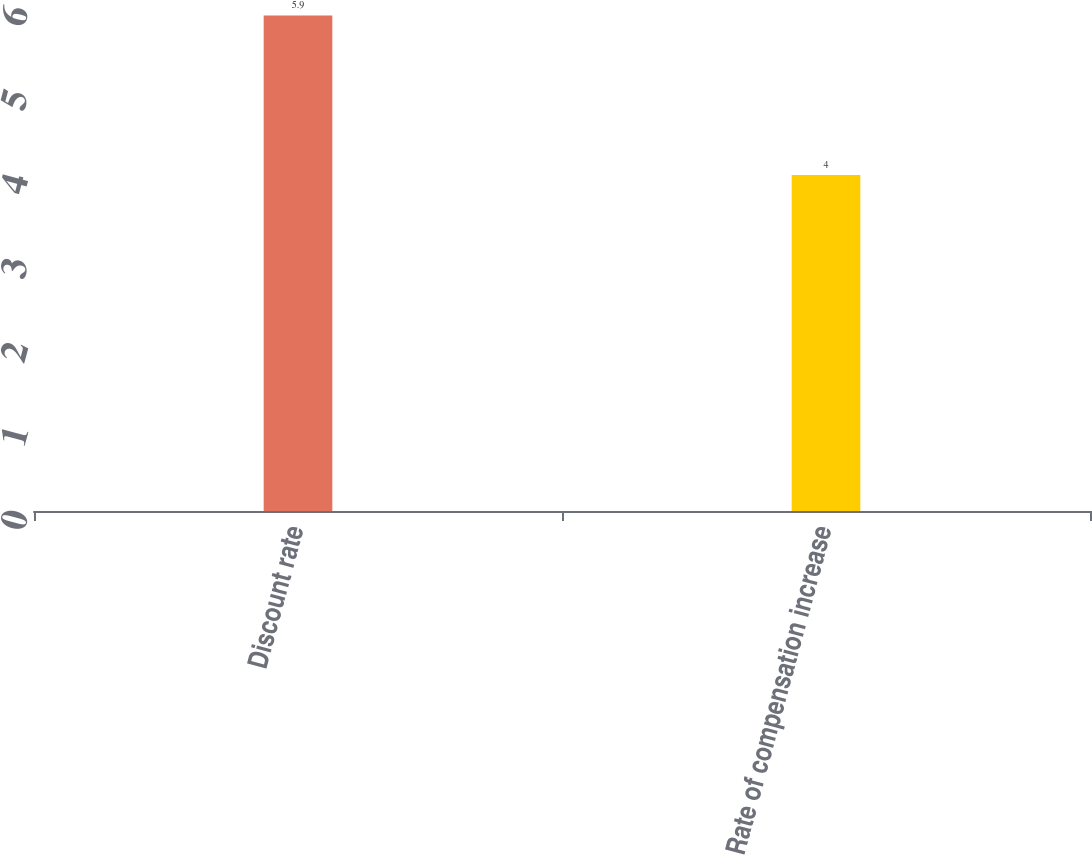Convert chart. <chart><loc_0><loc_0><loc_500><loc_500><bar_chart><fcel>Discount rate<fcel>Rate of compensation increase<nl><fcel>5.9<fcel>4<nl></chart> 